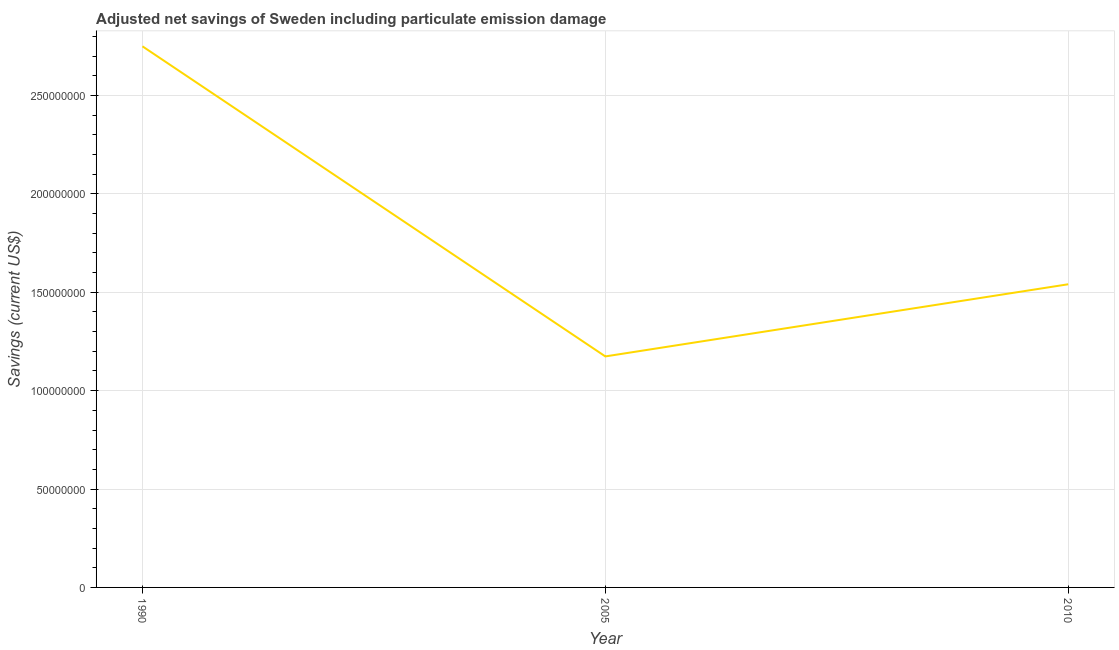What is the adjusted net savings in 2010?
Offer a terse response. 1.54e+08. Across all years, what is the maximum adjusted net savings?
Your answer should be very brief. 2.75e+08. Across all years, what is the minimum adjusted net savings?
Your answer should be very brief. 1.17e+08. What is the sum of the adjusted net savings?
Your answer should be compact. 5.46e+08. What is the difference between the adjusted net savings in 1990 and 2010?
Your response must be concise. 1.21e+08. What is the average adjusted net savings per year?
Make the answer very short. 1.82e+08. What is the median adjusted net savings?
Your answer should be very brief. 1.54e+08. In how many years, is the adjusted net savings greater than 100000000 US$?
Give a very brief answer. 3. What is the ratio of the adjusted net savings in 1990 to that in 2005?
Offer a terse response. 2.34. What is the difference between the highest and the second highest adjusted net savings?
Ensure brevity in your answer.  1.21e+08. What is the difference between the highest and the lowest adjusted net savings?
Offer a terse response. 1.58e+08. In how many years, is the adjusted net savings greater than the average adjusted net savings taken over all years?
Your response must be concise. 1. How many years are there in the graph?
Offer a very short reply. 3. What is the difference between two consecutive major ticks on the Y-axis?
Make the answer very short. 5.00e+07. Are the values on the major ticks of Y-axis written in scientific E-notation?
Offer a terse response. No. What is the title of the graph?
Make the answer very short. Adjusted net savings of Sweden including particulate emission damage. What is the label or title of the X-axis?
Keep it short and to the point. Year. What is the label or title of the Y-axis?
Keep it short and to the point. Savings (current US$). What is the Savings (current US$) in 1990?
Give a very brief answer. 2.75e+08. What is the Savings (current US$) in 2005?
Ensure brevity in your answer.  1.17e+08. What is the Savings (current US$) in 2010?
Offer a very short reply. 1.54e+08. What is the difference between the Savings (current US$) in 1990 and 2005?
Offer a very short reply. 1.58e+08. What is the difference between the Savings (current US$) in 1990 and 2010?
Keep it short and to the point. 1.21e+08. What is the difference between the Savings (current US$) in 2005 and 2010?
Your answer should be compact. -3.67e+07. What is the ratio of the Savings (current US$) in 1990 to that in 2005?
Make the answer very short. 2.34. What is the ratio of the Savings (current US$) in 1990 to that in 2010?
Your answer should be compact. 1.78. What is the ratio of the Savings (current US$) in 2005 to that in 2010?
Give a very brief answer. 0.76. 